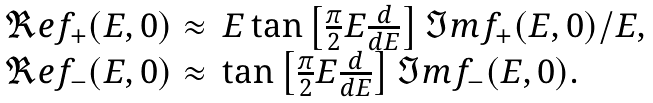Convert formula to latex. <formula><loc_0><loc_0><loc_500><loc_500>\begin{array} { l l } \Re e f _ { + } ( E , 0 ) \approx & E \tan \left [ \frac { \pi } { 2 } E \frac { d } { d E } \right ] \Im m f _ { + } ( E , 0 ) / E , \\ \Re e f _ { - } ( E , 0 ) \approx & \tan \left [ \frac { \pi } { 2 } E \frac { d } { d E } \right ] \Im m f _ { - } ( E , 0 ) . \end{array}</formula> 